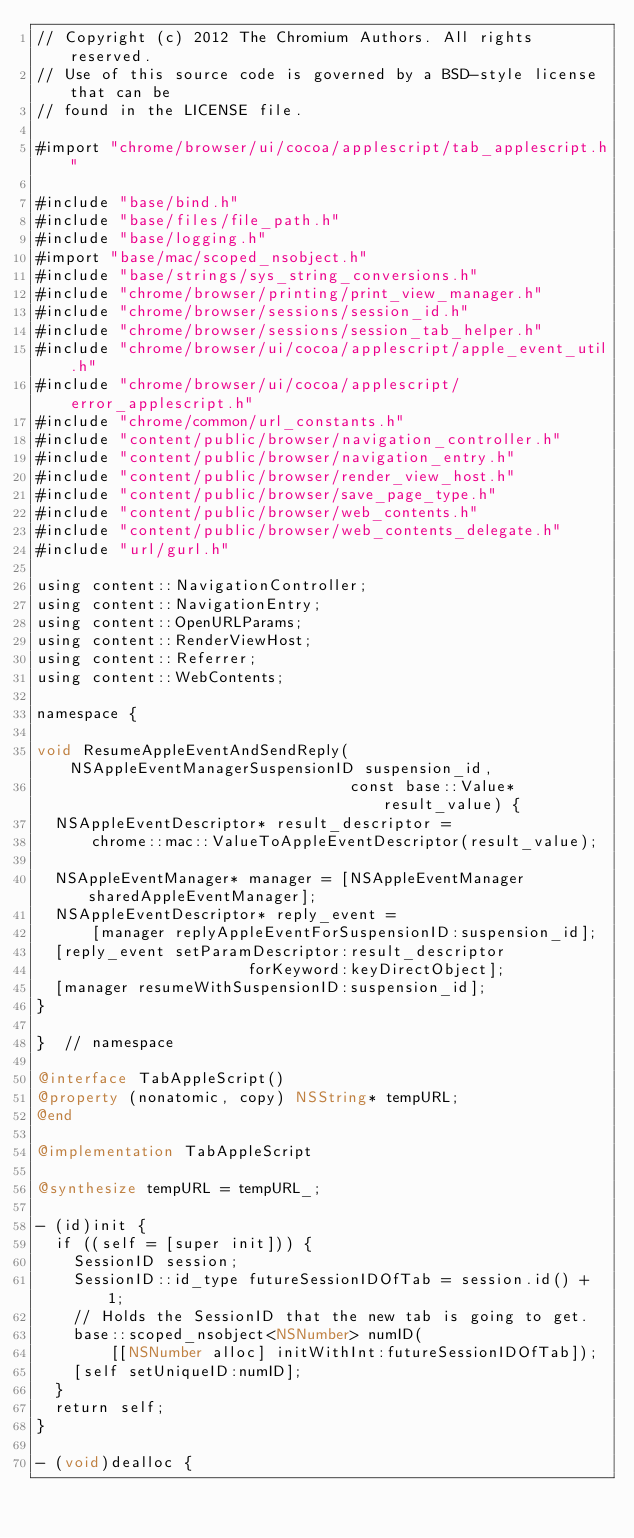<code> <loc_0><loc_0><loc_500><loc_500><_ObjectiveC_>// Copyright (c) 2012 The Chromium Authors. All rights reserved.
// Use of this source code is governed by a BSD-style license that can be
// found in the LICENSE file.

#import "chrome/browser/ui/cocoa/applescript/tab_applescript.h"

#include "base/bind.h"
#include "base/files/file_path.h"
#include "base/logging.h"
#import "base/mac/scoped_nsobject.h"
#include "base/strings/sys_string_conversions.h"
#include "chrome/browser/printing/print_view_manager.h"
#include "chrome/browser/sessions/session_id.h"
#include "chrome/browser/sessions/session_tab_helper.h"
#include "chrome/browser/ui/cocoa/applescript/apple_event_util.h"
#include "chrome/browser/ui/cocoa/applescript/error_applescript.h"
#include "chrome/common/url_constants.h"
#include "content/public/browser/navigation_controller.h"
#include "content/public/browser/navigation_entry.h"
#include "content/public/browser/render_view_host.h"
#include "content/public/browser/save_page_type.h"
#include "content/public/browser/web_contents.h"
#include "content/public/browser/web_contents_delegate.h"
#include "url/gurl.h"

using content::NavigationController;
using content::NavigationEntry;
using content::OpenURLParams;
using content::RenderViewHost;
using content::Referrer;
using content::WebContents;

namespace {

void ResumeAppleEventAndSendReply(NSAppleEventManagerSuspensionID suspension_id,
                                  const base::Value* result_value) {
  NSAppleEventDescriptor* result_descriptor =
      chrome::mac::ValueToAppleEventDescriptor(result_value);

  NSAppleEventManager* manager = [NSAppleEventManager sharedAppleEventManager];
  NSAppleEventDescriptor* reply_event =
      [manager replyAppleEventForSuspensionID:suspension_id];
  [reply_event setParamDescriptor:result_descriptor
                       forKeyword:keyDirectObject];
  [manager resumeWithSuspensionID:suspension_id];
}

}  // namespace

@interface TabAppleScript()
@property (nonatomic, copy) NSString* tempURL;
@end

@implementation TabAppleScript

@synthesize tempURL = tempURL_;

- (id)init {
  if ((self = [super init])) {
    SessionID session;
    SessionID::id_type futureSessionIDOfTab = session.id() + 1;
    // Holds the SessionID that the new tab is going to get.
    base::scoped_nsobject<NSNumber> numID(
        [[NSNumber alloc] initWithInt:futureSessionIDOfTab]);
    [self setUniqueID:numID];
  }
  return self;
}

- (void)dealloc {</code> 